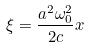<formula> <loc_0><loc_0><loc_500><loc_500>\xi = \frac { a ^ { 2 } \omega _ { 0 } ^ { 2 } } { 2 c } x</formula> 